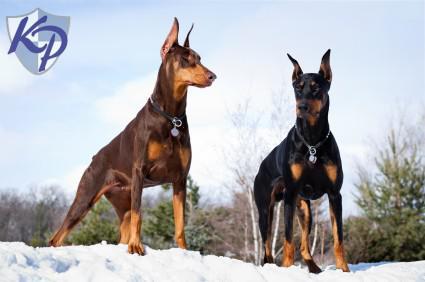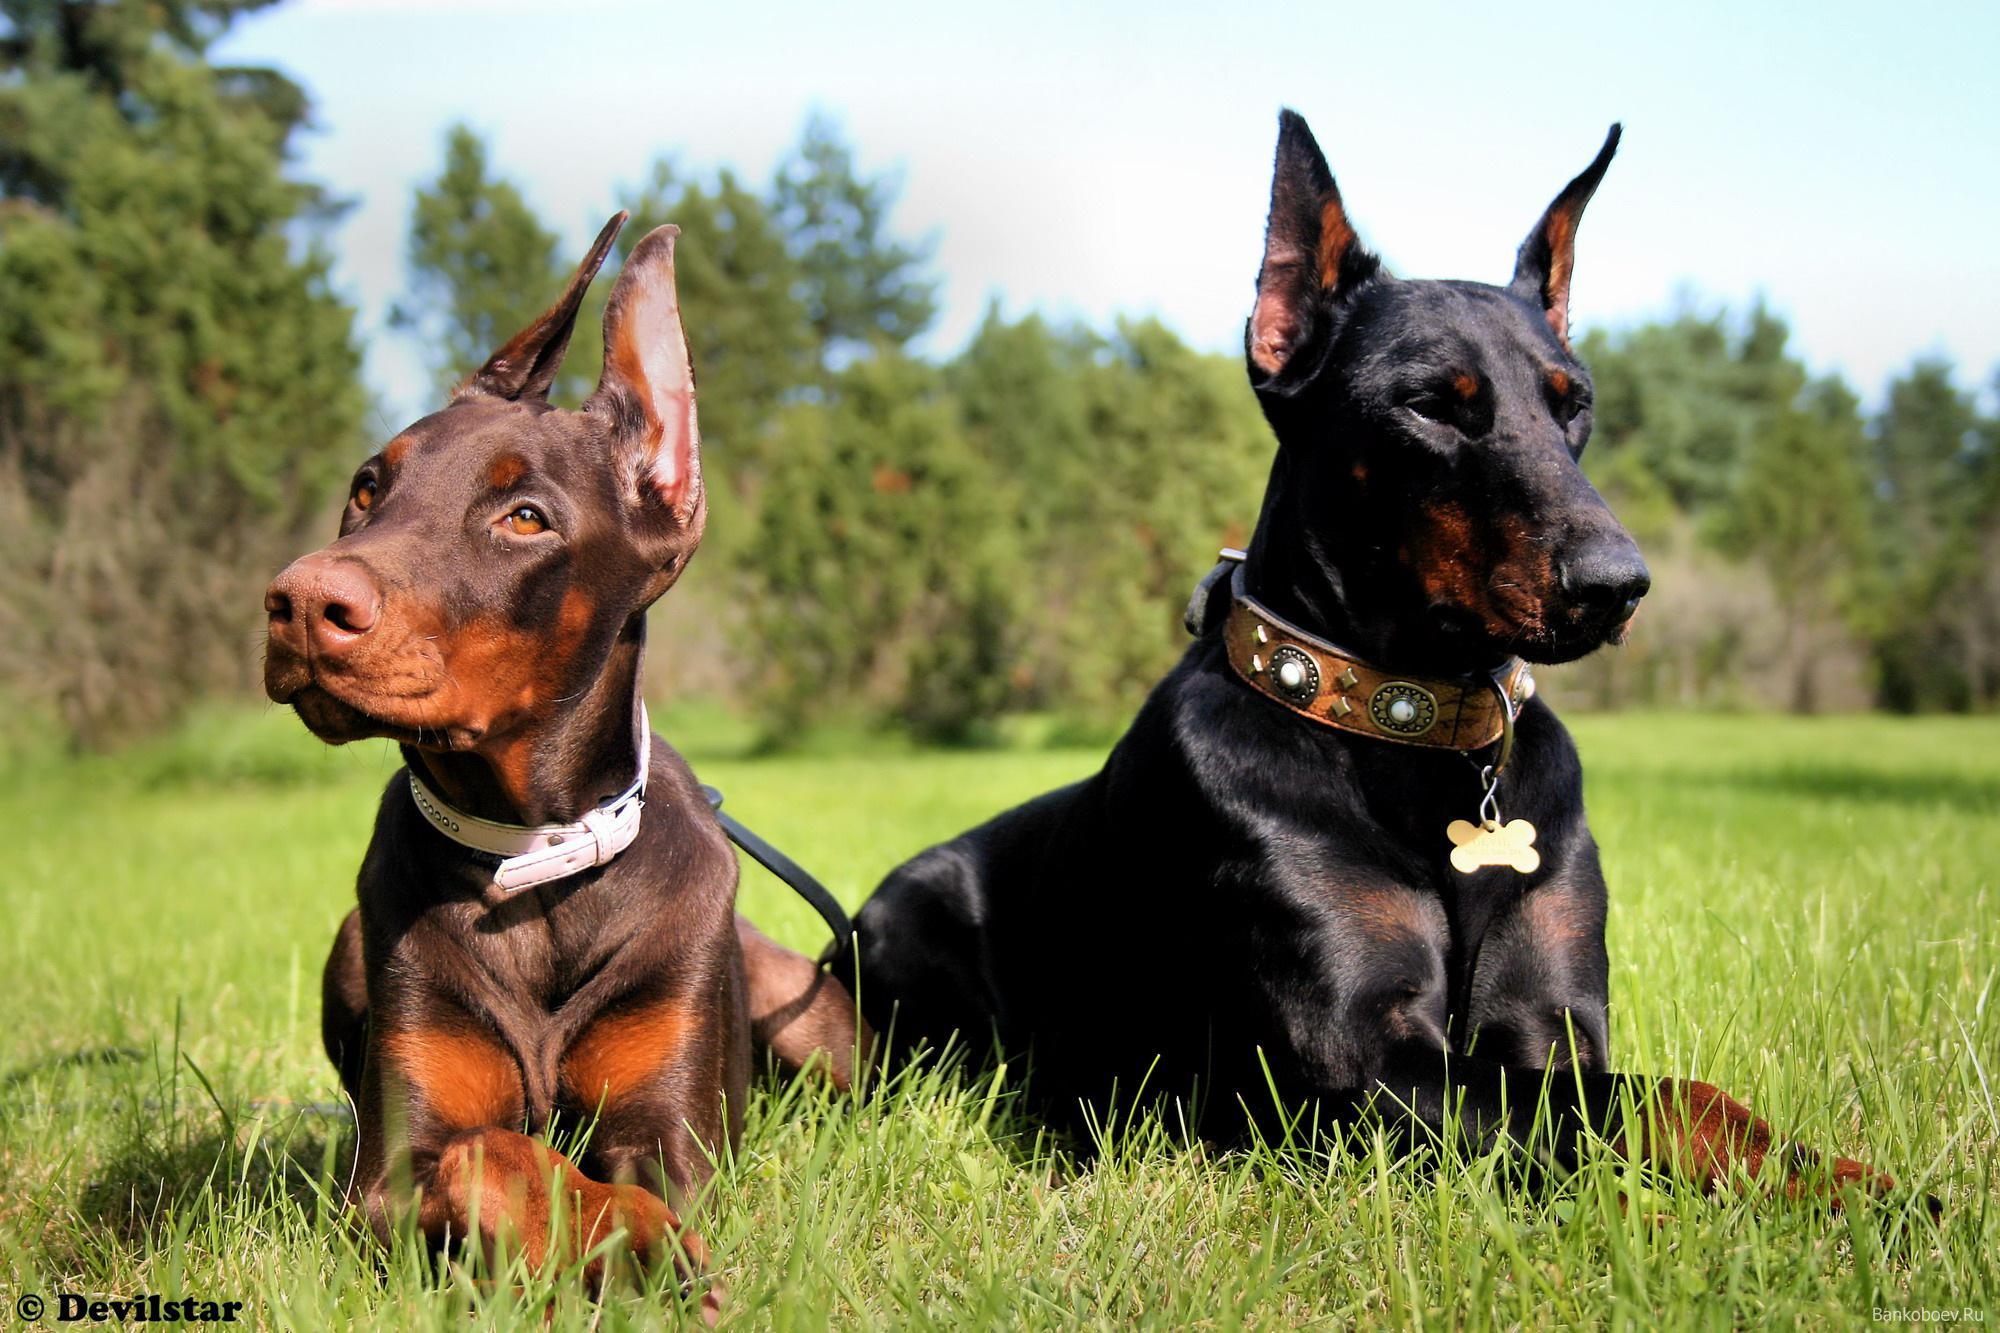The first image is the image on the left, the second image is the image on the right. Assess this claim about the two images: "There are two or more dogs standing in the left image and laying down in the right.". Correct or not? Answer yes or no. Yes. The first image is the image on the left, the second image is the image on the right. Evaluate the accuracy of this statement regarding the images: "The left image contains at least two dogs.". Is it true? Answer yes or no. Yes. 